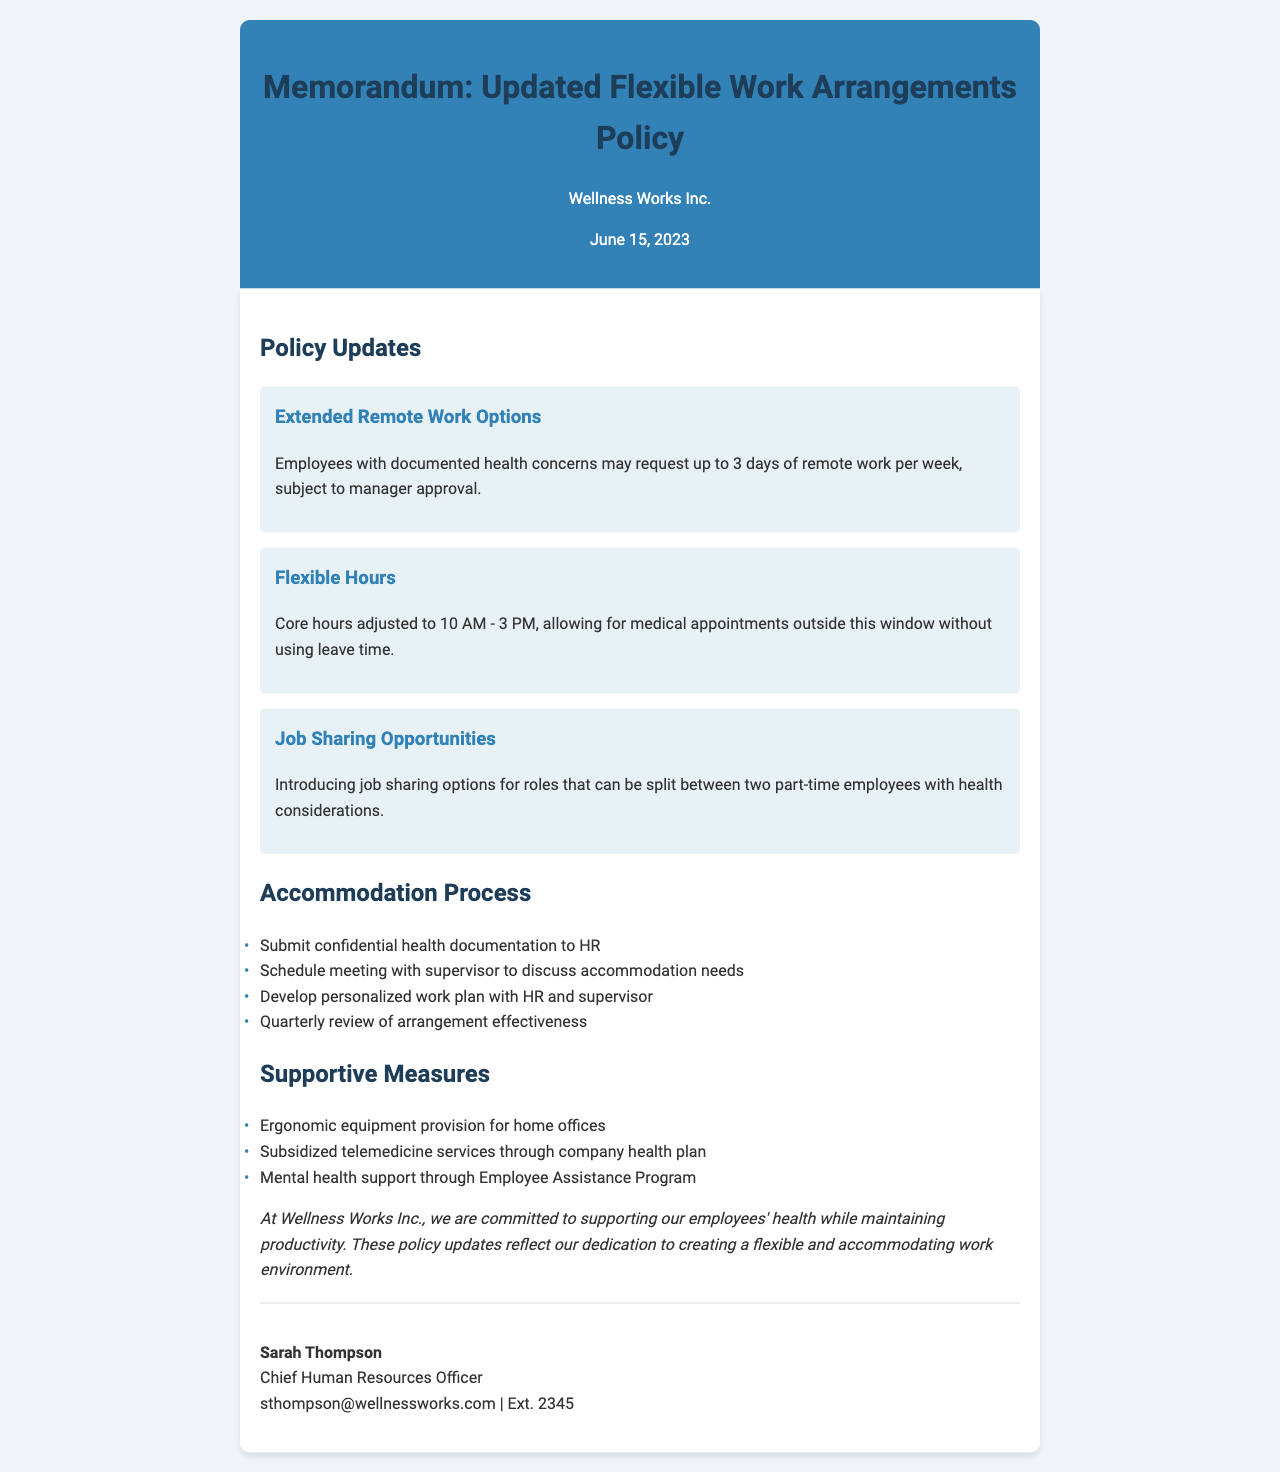What is the date of the memorandum? The date of the memorandum is clearly stated at the top of the document.
Answer: June 15, 2023 Who is the Chief Human Resources Officer? The Chief Human Resources Officer’s name is mentioned at the end of the document.
Answer: Sarah Thompson How many remote work days can employees request per week? This information is provided under the Extended Remote Work Options section.
Answer: 3 days What are the adjusted core hours mentioned in the policy? The adjusted core hours are specified under the Flexible Hours section.
Answer: 10 AM - 3 PM What is one supportive measure mentioned in the document? This refers to any of the supportive measures listed in the document.
Answer: Ergonomic equipment provision for home offices What process must be followed to request accommodations? The steps are outlined under the Accommodation Process section.
Answer: Submit confidential health documentation to HR How often is the arrangement effectiveness reviewed? This detail is found in the Accommodation Process section.
Answer: Quarterly What company is this policy for? The company name is mentioned at the beginning of the document.
Answer: Wellness Works Inc 